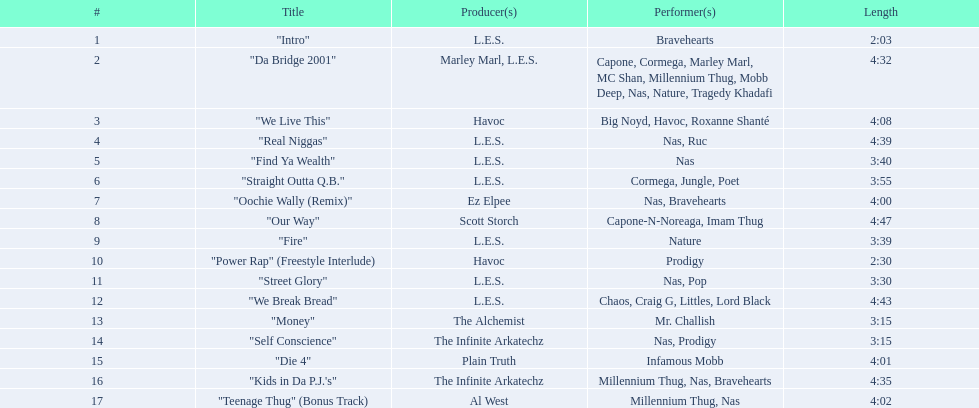After street glory, what song is listed? "We Break Bread". 